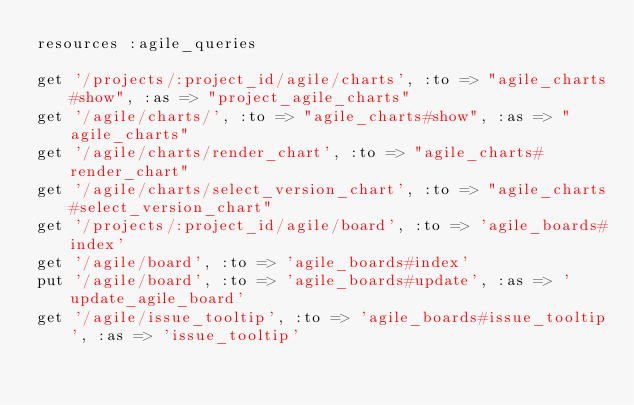Convert code to text. <code><loc_0><loc_0><loc_500><loc_500><_Ruby_>resources :agile_queries

get '/projects/:project_id/agile/charts', :to => "agile_charts#show", :as => "project_agile_charts"
get '/agile/charts/', :to => "agile_charts#show", :as => "agile_charts"
get '/agile/charts/render_chart', :to => "agile_charts#render_chart"
get '/agile/charts/select_version_chart', :to => "agile_charts#select_version_chart"
get '/projects/:project_id/agile/board', :to => 'agile_boards#index'
get '/agile/board', :to => 'agile_boards#index'
put '/agile/board', :to => 'agile_boards#update', :as => 'update_agile_board'
get '/agile/issue_tooltip', :to => 'agile_boards#issue_tooltip', :as => 'issue_tooltip'
</code> 